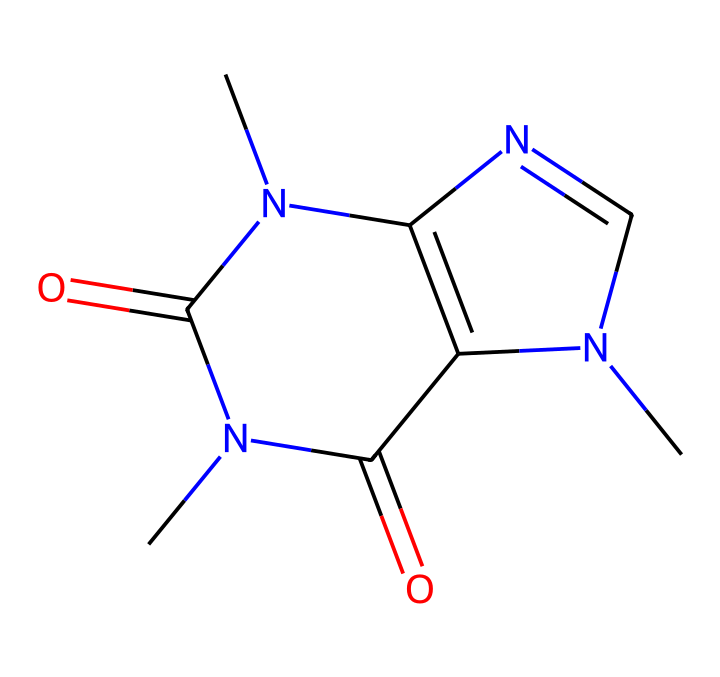What is the molecular formula of caffeine? To determine the molecular formula, count the number of each type of atom in the chemical structure. The SMILES representation contains the following types of atoms: 8 carbon (C) atoms, 10 hydrogen (H) atoms, 4 nitrogen (N) atoms, and 2 oxygen (O) atoms. Putting these together gives the molecular formula C8H10N4O2.
Answer: C8H10N4O2 How many nitrogen atoms are present in the structure? By examining the SMILES representation, we can identify the nitrogen (N) atoms. In this structure, there are four nitrogen atoms, which can be spotted by their occurrence in the formula.
Answer: 4 What type of compound is caffeine classified as? Caffeine is classified as an alkaloid due to its complex nitrogen-containing structure, which typically includes aromatic rings. This classification is based on the presence of nitrogen-containing groups and their biological activity.
Answer: alkaloid What is the degree of unsaturation calculated for caffeine? The degree of unsaturation indicates the number of rings and multiple bonds present. To calculate it, use the formula: Degree of unsaturation = (2C + 2 + N - H - X)/2, where C is the number of carbon atoms, N is nitrogen, H is hydrogen, and X is halogens (none in this case). Plugging in C=8, N=4, and H=10 gives us a degree of unsaturation of 4, indicating the presence of rings and/or double bonds in the structure.
Answer: 4 Does caffeine interact with metal ions as an organometallic compound? While caffeine itself is not an organometallic compound and does not typically contain metal atoms, certain organometallic complexes can be formed with caffeine as a ligand. These interactions can affect the biological activity of caffeine, particularly in pharmacology, but caffeine itself does not exhibit organometallic characteristics.
Answer: no What functional groups are present in the caffeine structure? Upon examining the structure, we can identify amine groups due to the nitrogen atoms and carbonyl groups from the carbon-oxygen double bonds. This combination contributes to caffeine's properties. By recognizing these connections, it can be seen that the functional groups are primarily amines and carbonyls.
Answer: amine and carbonyl What is the primary role of the nitrogen atoms in caffeine's effect on the body? The nitrogen atoms are crucial in forming the structure of caffeine, contributing to its ability to bind to adenosine receptors in the brain, which is why it's known for its stimulant effects. The configuration around these nitrogen centers influences how caffeine interacts with biological systems.
Answer: stimulant effects 